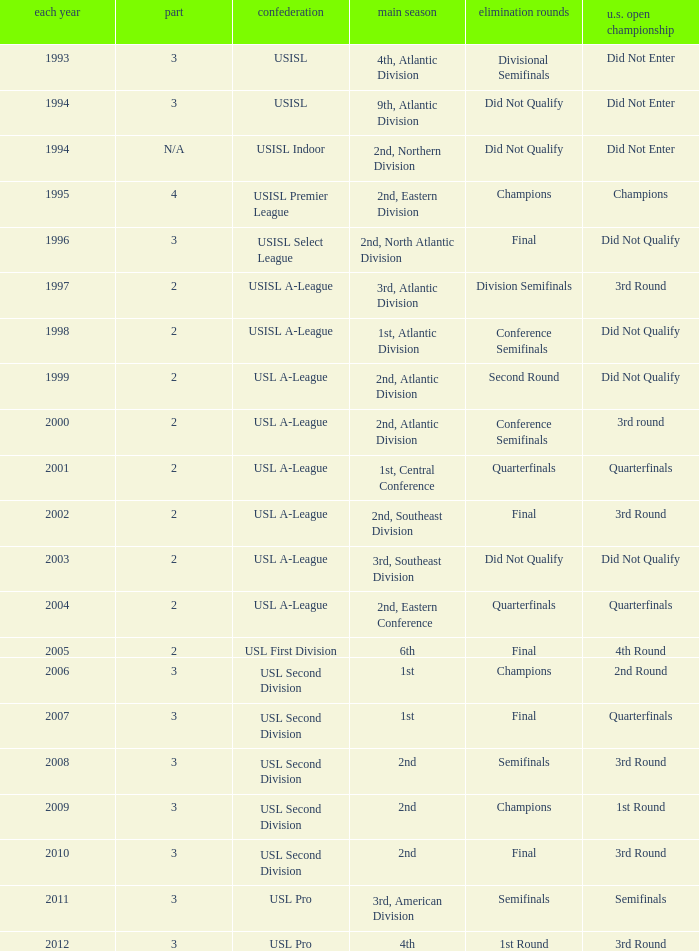How many division  did not qualify for u.s. open cup in 2003 2.0. 